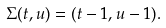<formula> <loc_0><loc_0><loc_500><loc_500>\Sigma ( t , u ) = ( t - 1 , u - 1 ) .</formula> 